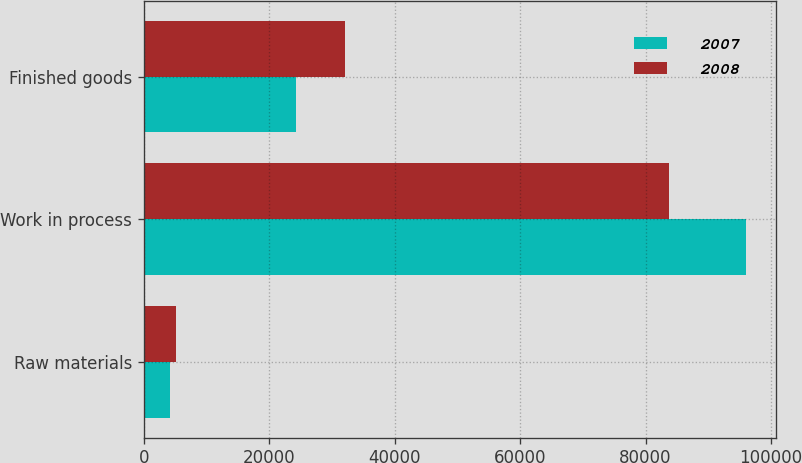<chart> <loc_0><loc_0><loc_500><loc_500><stacked_bar_chart><ecel><fcel>Raw materials<fcel>Work in process<fcel>Finished goods<nl><fcel>2007<fcel>4205<fcel>95973<fcel>24305<nl><fcel>2008<fcel>5118<fcel>83783<fcel>32123<nl></chart> 